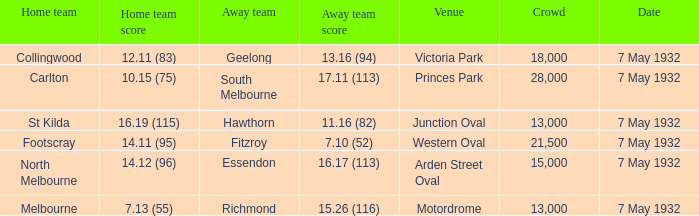What is the away team with a Crowd greater than 13,000, and a Home team score of 12.11 (83)? Geelong. 